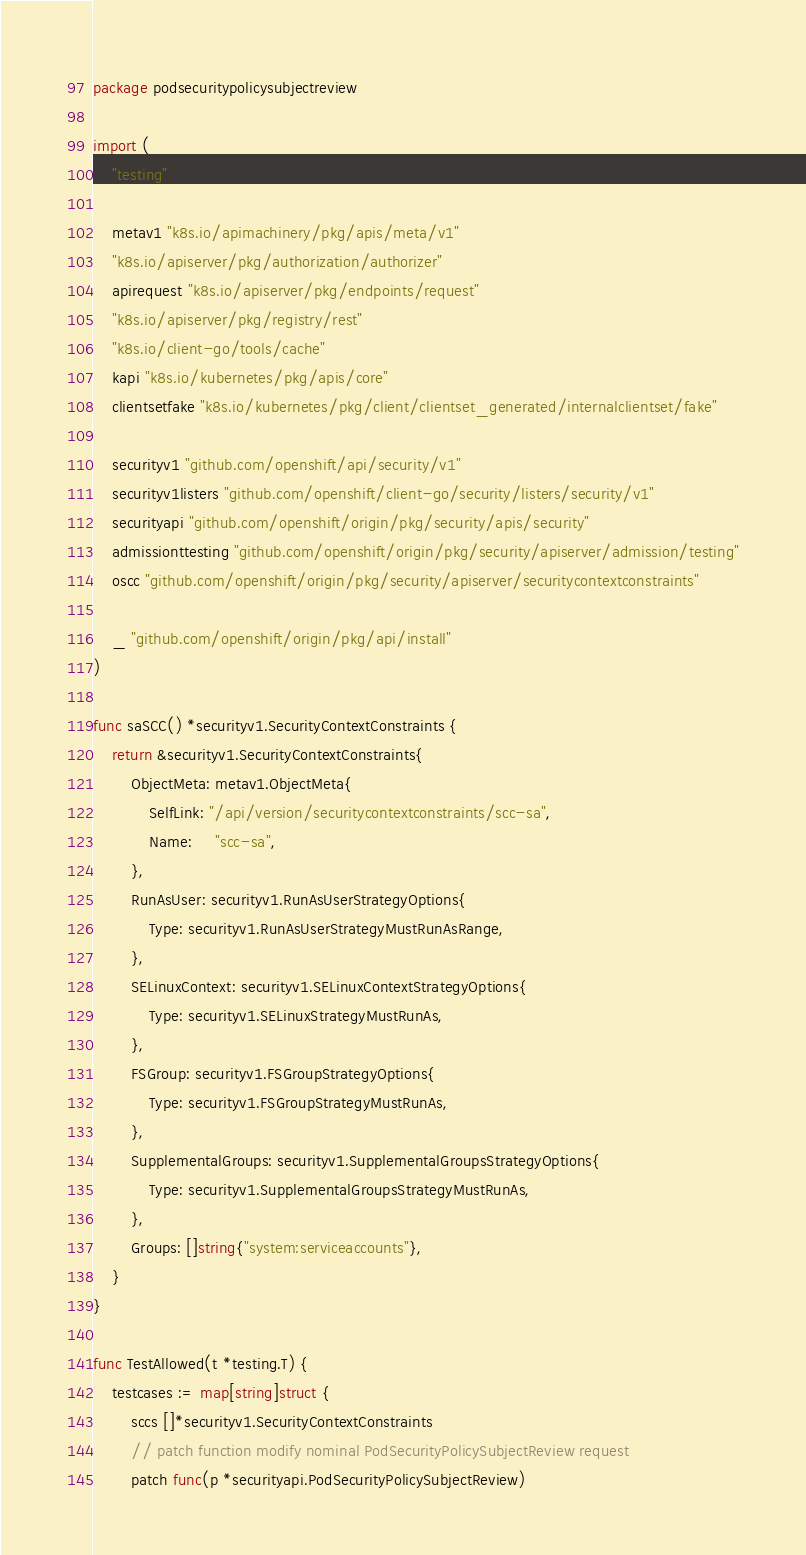<code> <loc_0><loc_0><loc_500><loc_500><_Go_>package podsecuritypolicysubjectreview

import (
	"testing"

	metav1 "k8s.io/apimachinery/pkg/apis/meta/v1"
	"k8s.io/apiserver/pkg/authorization/authorizer"
	apirequest "k8s.io/apiserver/pkg/endpoints/request"
	"k8s.io/apiserver/pkg/registry/rest"
	"k8s.io/client-go/tools/cache"
	kapi "k8s.io/kubernetes/pkg/apis/core"
	clientsetfake "k8s.io/kubernetes/pkg/client/clientset_generated/internalclientset/fake"

	securityv1 "github.com/openshift/api/security/v1"
	securityv1listers "github.com/openshift/client-go/security/listers/security/v1"
	securityapi "github.com/openshift/origin/pkg/security/apis/security"
	admissionttesting "github.com/openshift/origin/pkg/security/apiserver/admission/testing"
	oscc "github.com/openshift/origin/pkg/security/apiserver/securitycontextconstraints"

	_ "github.com/openshift/origin/pkg/api/install"
)

func saSCC() *securityv1.SecurityContextConstraints {
	return &securityv1.SecurityContextConstraints{
		ObjectMeta: metav1.ObjectMeta{
			SelfLink: "/api/version/securitycontextconstraints/scc-sa",
			Name:     "scc-sa",
		},
		RunAsUser: securityv1.RunAsUserStrategyOptions{
			Type: securityv1.RunAsUserStrategyMustRunAsRange,
		},
		SELinuxContext: securityv1.SELinuxContextStrategyOptions{
			Type: securityv1.SELinuxStrategyMustRunAs,
		},
		FSGroup: securityv1.FSGroupStrategyOptions{
			Type: securityv1.FSGroupStrategyMustRunAs,
		},
		SupplementalGroups: securityv1.SupplementalGroupsStrategyOptions{
			Type: securityv1.SupplementalGroupsStrategyMustRunAs,
		},
		Groups: []string{"system:serviceaccounts"},
	}
}

func TestAllowed(t *testing.T) {
	testcases := map[string]struct {
		sccs []*securityv1.SecurityContextConstraints
		// patch function modify nominal PodSecurityPolicySubjectReview request
		patch func(p *securityapi.PodSecurityPolicySubjectReview)</code> 